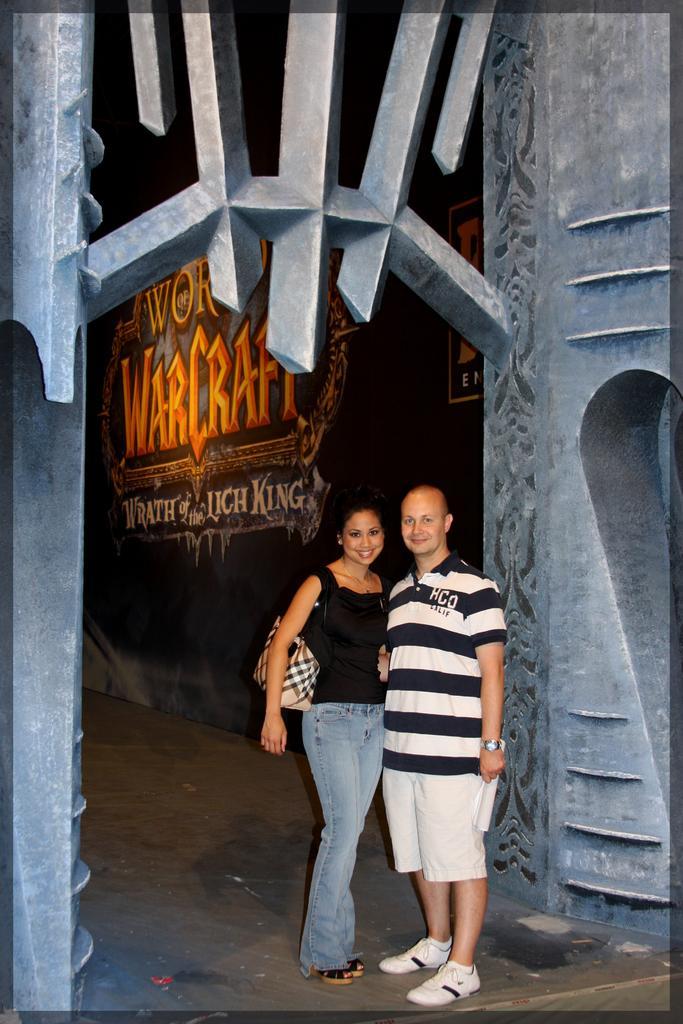In one or two sentences, can you explain what this image depicts? In this picture there is a man and a woman in the center of the image and there is a poster in the background area of the image. 